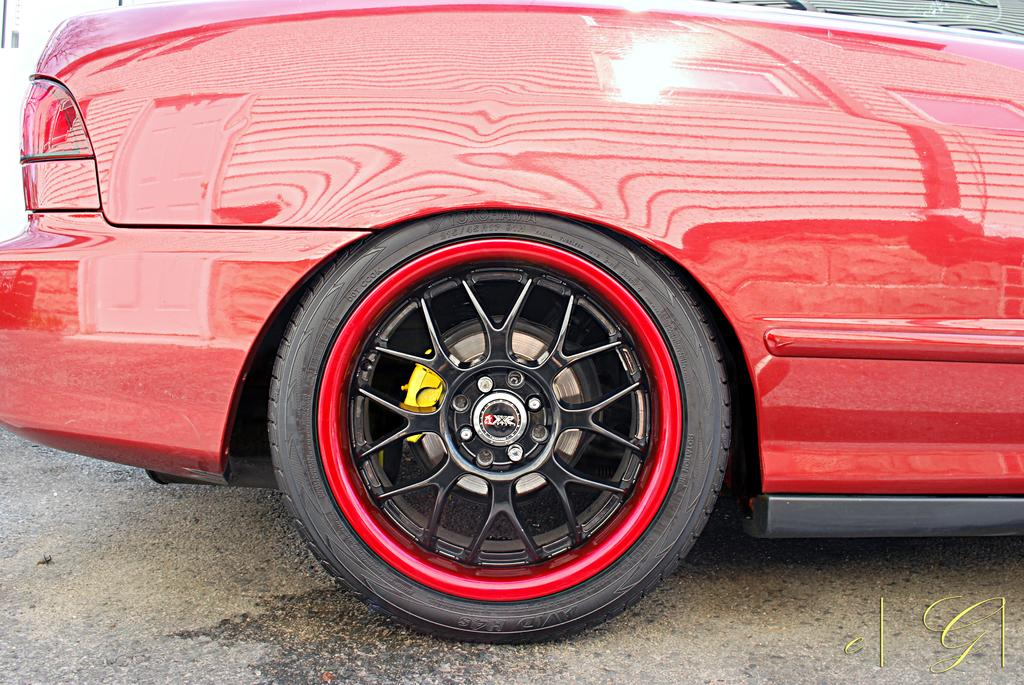What is the main subject of the image? The main subject of the image is a car. How is the car positioned in the image? The car is shown from the backside in the image. What type of surface is visible at the bottom of the image? There is ground visible at the bottom of the image. Is there any additional marking or feature on the image? Yes, there is a watermark on the image. What type of quiver can be seen hanging from the car in the image? There is no quiver present in the image, and the car is not shown with any attachments or accessories. 